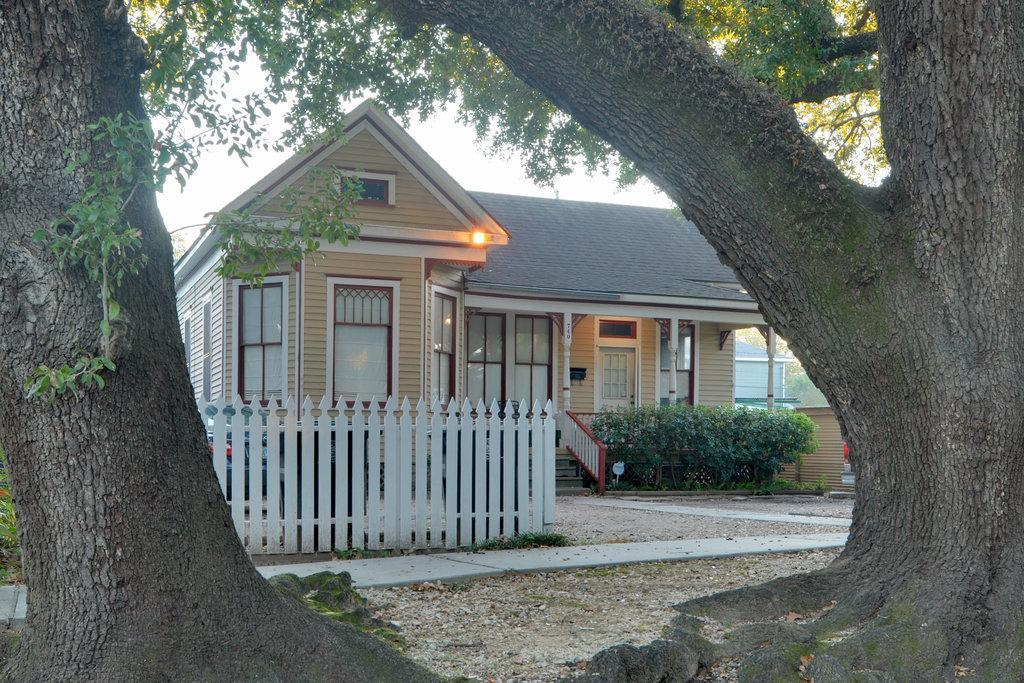Please provide a concise description of this image. There are trees. In the back there is a house with windows, doors, pillars. In front of the house there are steps with railings. Near to that there are bushes. Also there is a wooden fencing. 